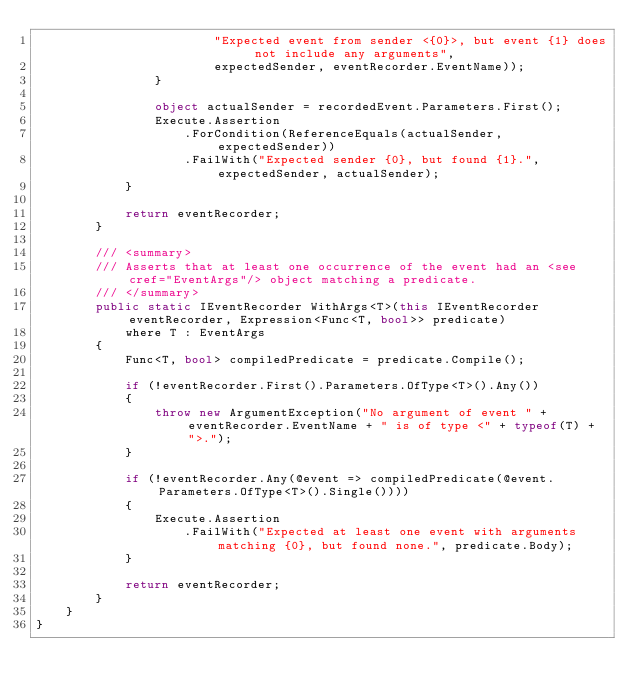Convert code to text. <code><loc_0><loc_0><loc_500><loc_500><_C#_>                        "Expected event from sender <{0}>, but event {1} does not include any arguments",
                        expectedSender, eventRecorder.EventName));
                }

                object actualSender = recordedEvent.Parameters.First();
                Execute.Assertion
                    .ForCondition(ReferenceEquals(actualSender, expectedSender))
                    .FailWith("Expected sender {0}, but found {1}.", expectedSender, actualSender);
            }

            return eventRecorder;
        }

        /// <summary>
        /// Asserts that at least one occurrence of the event had an <see cref="EventArgs"/> object matching a predicate.
        /// </summary>
        public static IEventRecorder WithArgs<T>(this IEventRecorder eventRecorder, Expression<Func<T, bool>> predicate)
            where T : EventArgs
        {
            Func<T, bool> compiledPredicate = predicate.Compile();

            if (!eventRecorder.First().Parameters.OfType<T>().Any())
            {
                throw new ArgumentException("No argument of event " + eventRecorder.EventName + " is of type <" + typeof(T) + ">.");
            }

            if (!eventRecorder.Any(@event => compiledPredicate(@event.Parameters.OfType<T>().Single())))
            {
                Execute.Assertion
                    .FailWith("Expected at least one event with arguments matching {0}, but found none.", predicate.Body);
            }

            return eventRecorder;
        }
    }
}</code> 